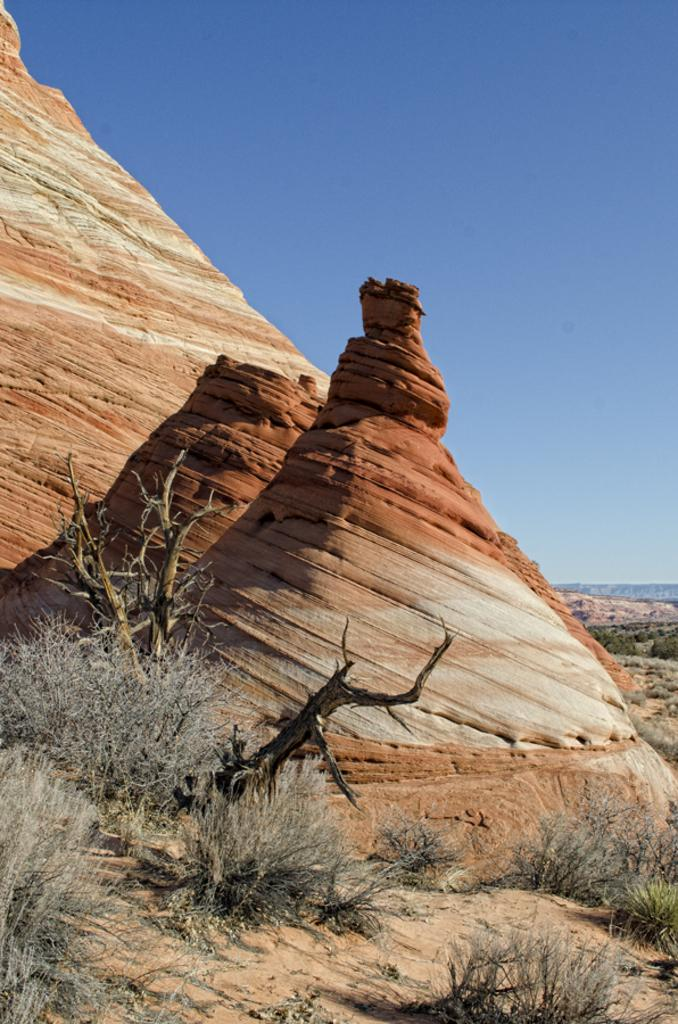What type of landscape is depicted in the image? The image features hills. What can be seen on the hills? There are trees on the hills. What is visible at the top of the image? The sky is visible at the top of the image. What type of dust can be seen covering the trees in the image? There is no dust present in the image; the trees appear to be clear of any debris. 